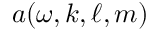<formula> <loc_0><loc_0><loc_500><loc_500>a ( \omega , k , \ell , m )</formula> 